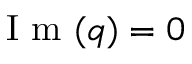<formula> <loc_0><loc_0><loc_500><loc_500>I m ( q ) = 0</formula> 